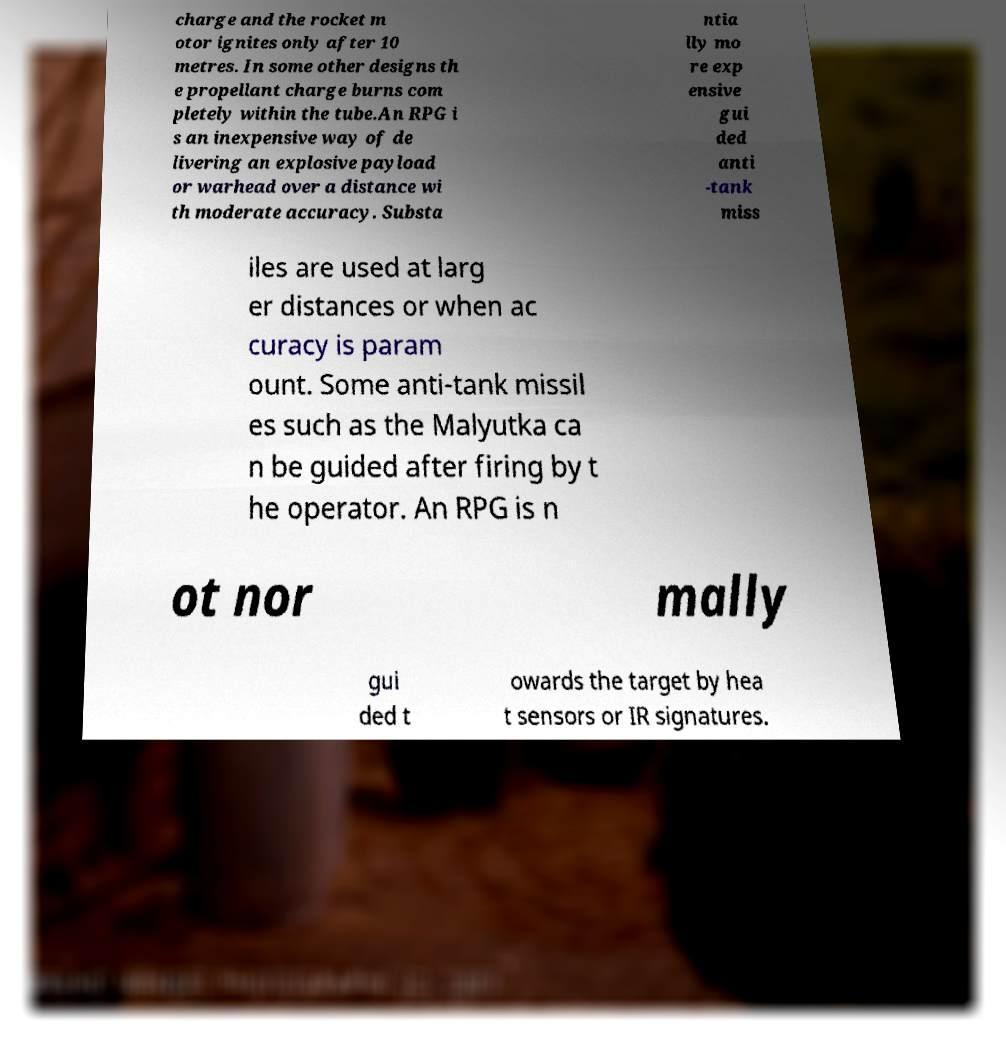Please identify and transcribe the text found in this image. charge and the rocket m otor ignites only after 10 metres. In some other designs th e propellant charge burns com pletely within the tube.An RPG i s an inexpensive way of de livering an explosive payload or warhead over a distance wi th moderate accuracy. Substa ntia lly mo re exp ensive gui ded anti -tank miss iles are used at larg er distances or when ac curacy is param ount. Some anti-tank missil es such as the Malyutka ca n be guided after firing by t he operator. An RPG is n ot nor mally gui ded t owards the target by hea t sensors or IR signatures. 